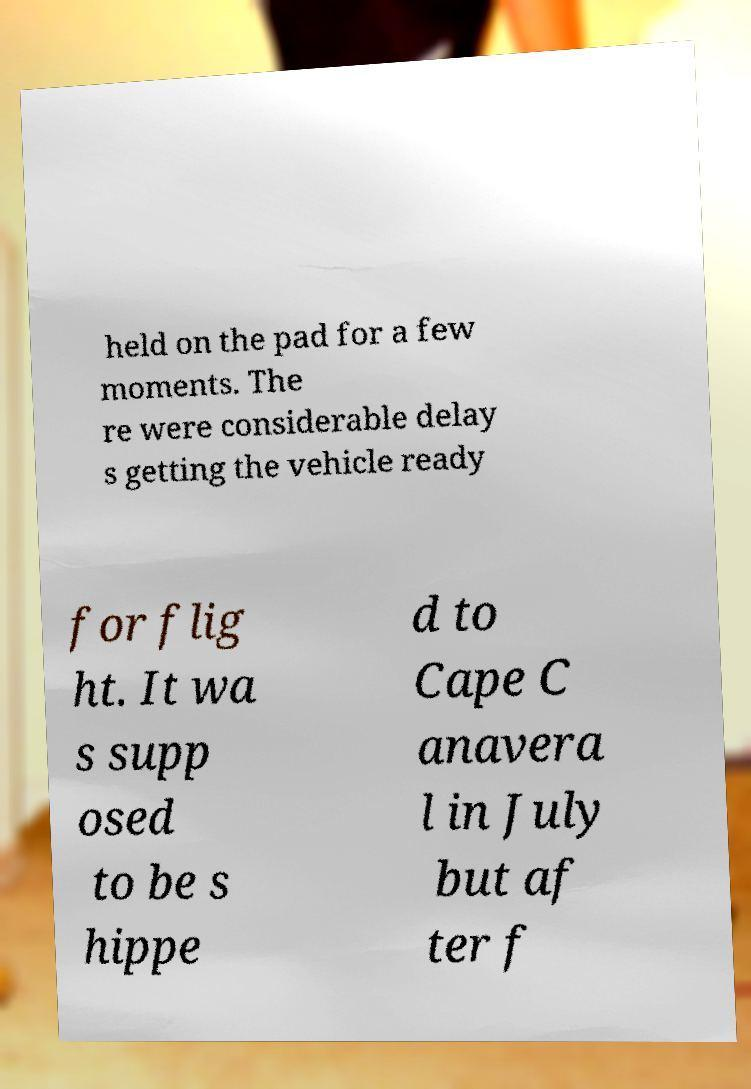Please identify and transcribe the text found in this image. held on the pad for a few moments. The re were considerable delay s getting the vehicle ready for flig ht. It wa s supp osed to be s hippe d to Cape C anavera l in July but af ter f 